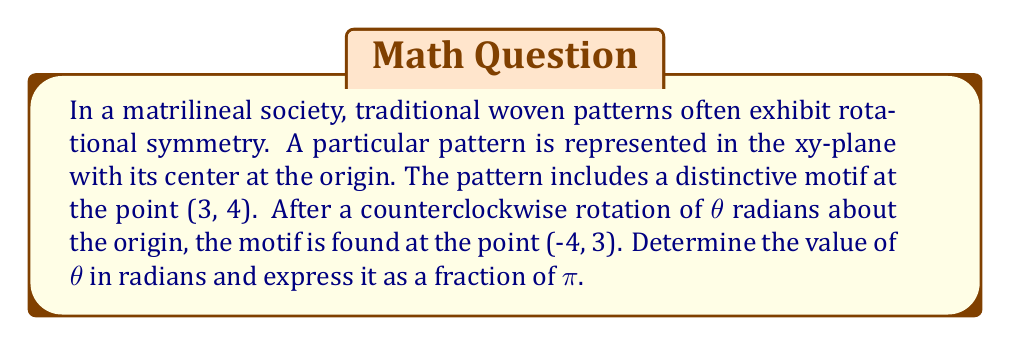Give your solution to this math problem. To solve this problem, we'll use the rotation matrix and follow these steps:

1) The general rotation matrix for a counterclockwise rotation by $\theta$ radians is:

   $$R(\theta) = \begin{pmatrix} 
   \cos\theta & -\sin\theta \\
   \sin\theta & \cos\theta 
   \end{pmatrix}$$

2) When we apply this rotation to the point (3, 4), we get the new point (-4, 3). We can express this as a matrix equation:

   $$\begin{pmatrix} 
   \cos\theta & -\sin\theta \\
   \sin\theta & \cos\theta 
   \end{pmatrix}
   \begin{pmatrix} 
   3 \\
   4 
   \end{pmatrix} =
   \begin{pmatrix} 
   -4 \\
   3 
   \end{pmatrix}$$

3) This gives us two equations:
   
   $3\cos\theta - 4\sin\theta = -4$
   $3\sin\theta + 4\cos\theta = 3$

4) From the second equation:
   
   $\cos\theta = \frac{3 - 3\sin\theta}{4}$

5) Substitute this into the first equation:

   $3(\frac{3 - 3\sin\theta}{4}) - 4\sin\theta = -4$

6) Simplify:

   $\frac{9 - 9\sin\theta}{4} - 4\sin\theta = -4$
   $9 - 9\sin\theta - 16\sin\theta = -16$
   $9 - 25\sin\theta = -16$
   $25\sin\theta = 25$
   $\sin\theta = 1$

7) The solution to $\sin\theta = 1$ in the range $[0, 2\pi]$ is $\theta = \frac{\pi}{2}$

8) We can verify this with $\cos\theta = 0$, which satisfies our equations.

Therefore, the rotation angle $\theta$ is $\frac{\pi}{2}$ radians.
Answer: $\theta = \frac{\pi}{2}$ radians 